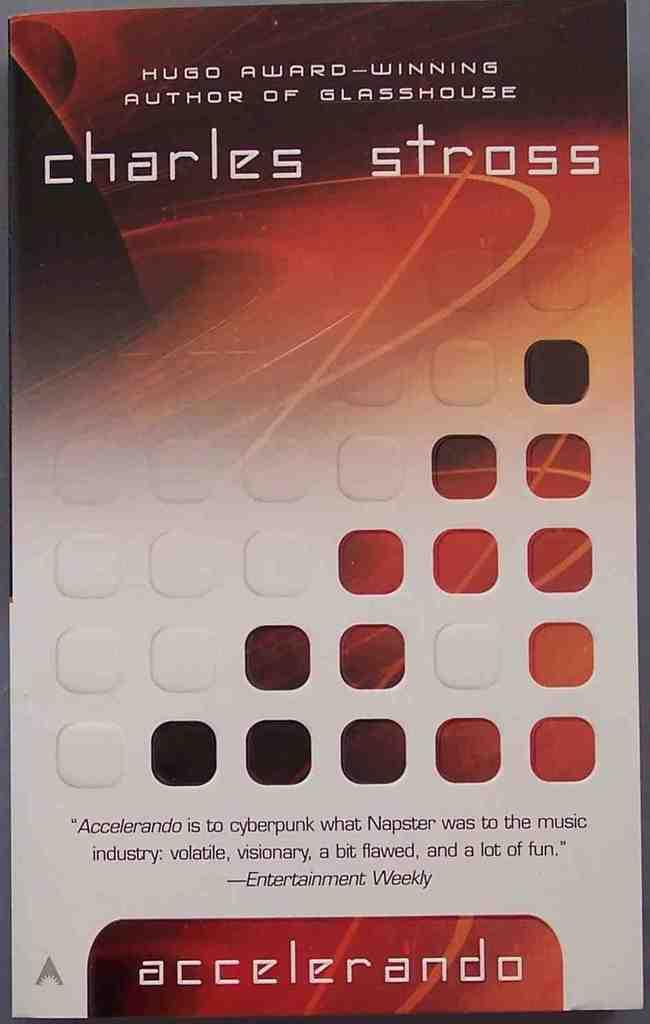<image>
Create a compact narrative representing the image presented. A book cover that says Charles Stross on it. 